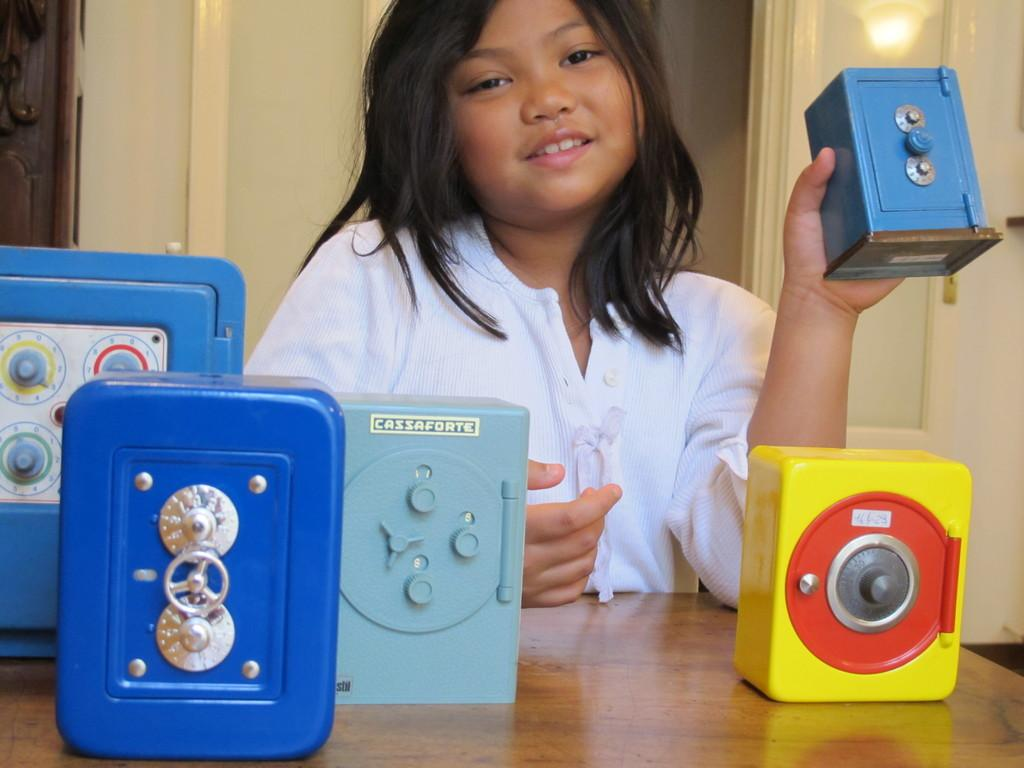Who is the main subject in the image? There is a girl in the image. What is the girl holding in the image? The girl is holding a box. Are there any other boxes visible in the image? Yes, there are boxes visible in front of the girl. What type of wing can be seen on the girl in the image? There is no wing visible on the girl in the image. What kind of beast is present in the image? There is no beast present in the image; it features a girl holding a box and other boxes in front of her. 